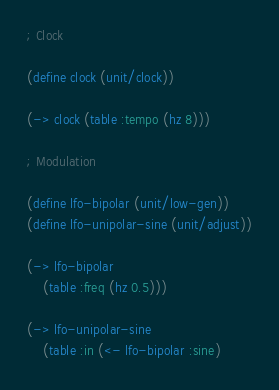<code> <loc_0><loc_0><loc_500><loc_500><_Lisp_>; Clock

(define clock (unit/clock))

(-> clock (table :tempo (hz 8)))

; Modulation

(define lfo-bipolar (unit/low-gen))
(define lfo-unipolar-sine (unit/adjust))

(-> lfo-bipolar
    (table :freq (hz 0.5)))

(-> lfo-unipolar-sine
    (table :in (<- lfo-bipolar :sine)</code> 